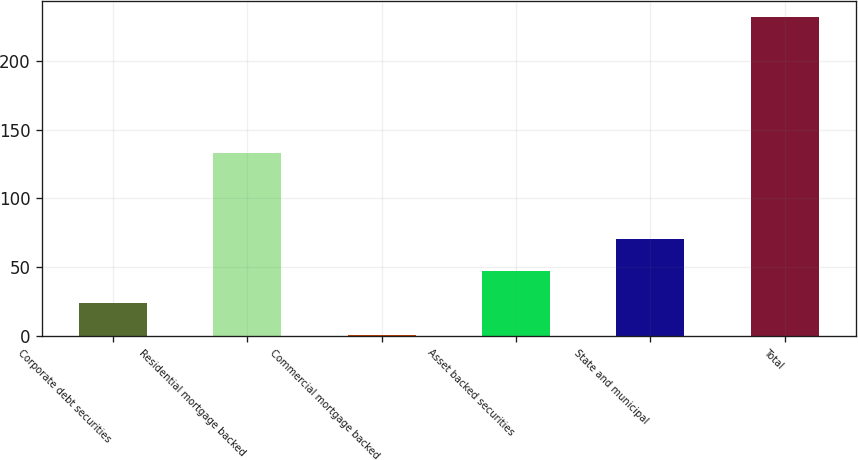Convert chart to OTSL. <chart><loc_0><loc_0><loc_500><loc_500><bar_chart><fcel>Corporate debt securities<fcel>Residential mortgage backed<fcel>Commercial mortgage backed<fcel>Asset backed securities<fcel>State and municipal<fcel>Total<nl><fcel>24.1<fcel>133<fcel>1<fcel>47.2<fcel>70.3<fcel>232<nl></chart> 